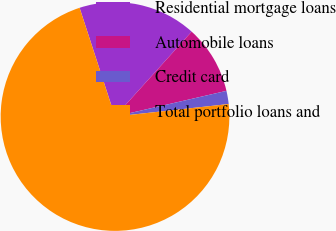Convert chart to OTSL. <chart><loc_0><loc_0><loc_500><loc_500><pie_chart><fcel>Residential mortgage loans<fcel>Automobile loans<fcel>Credit card<fcel>Total portfolio loans and<nl><fcel>16.7%<fcel>9.71%<fcel>1.86%<fcel>71.73%<nl></chart> 